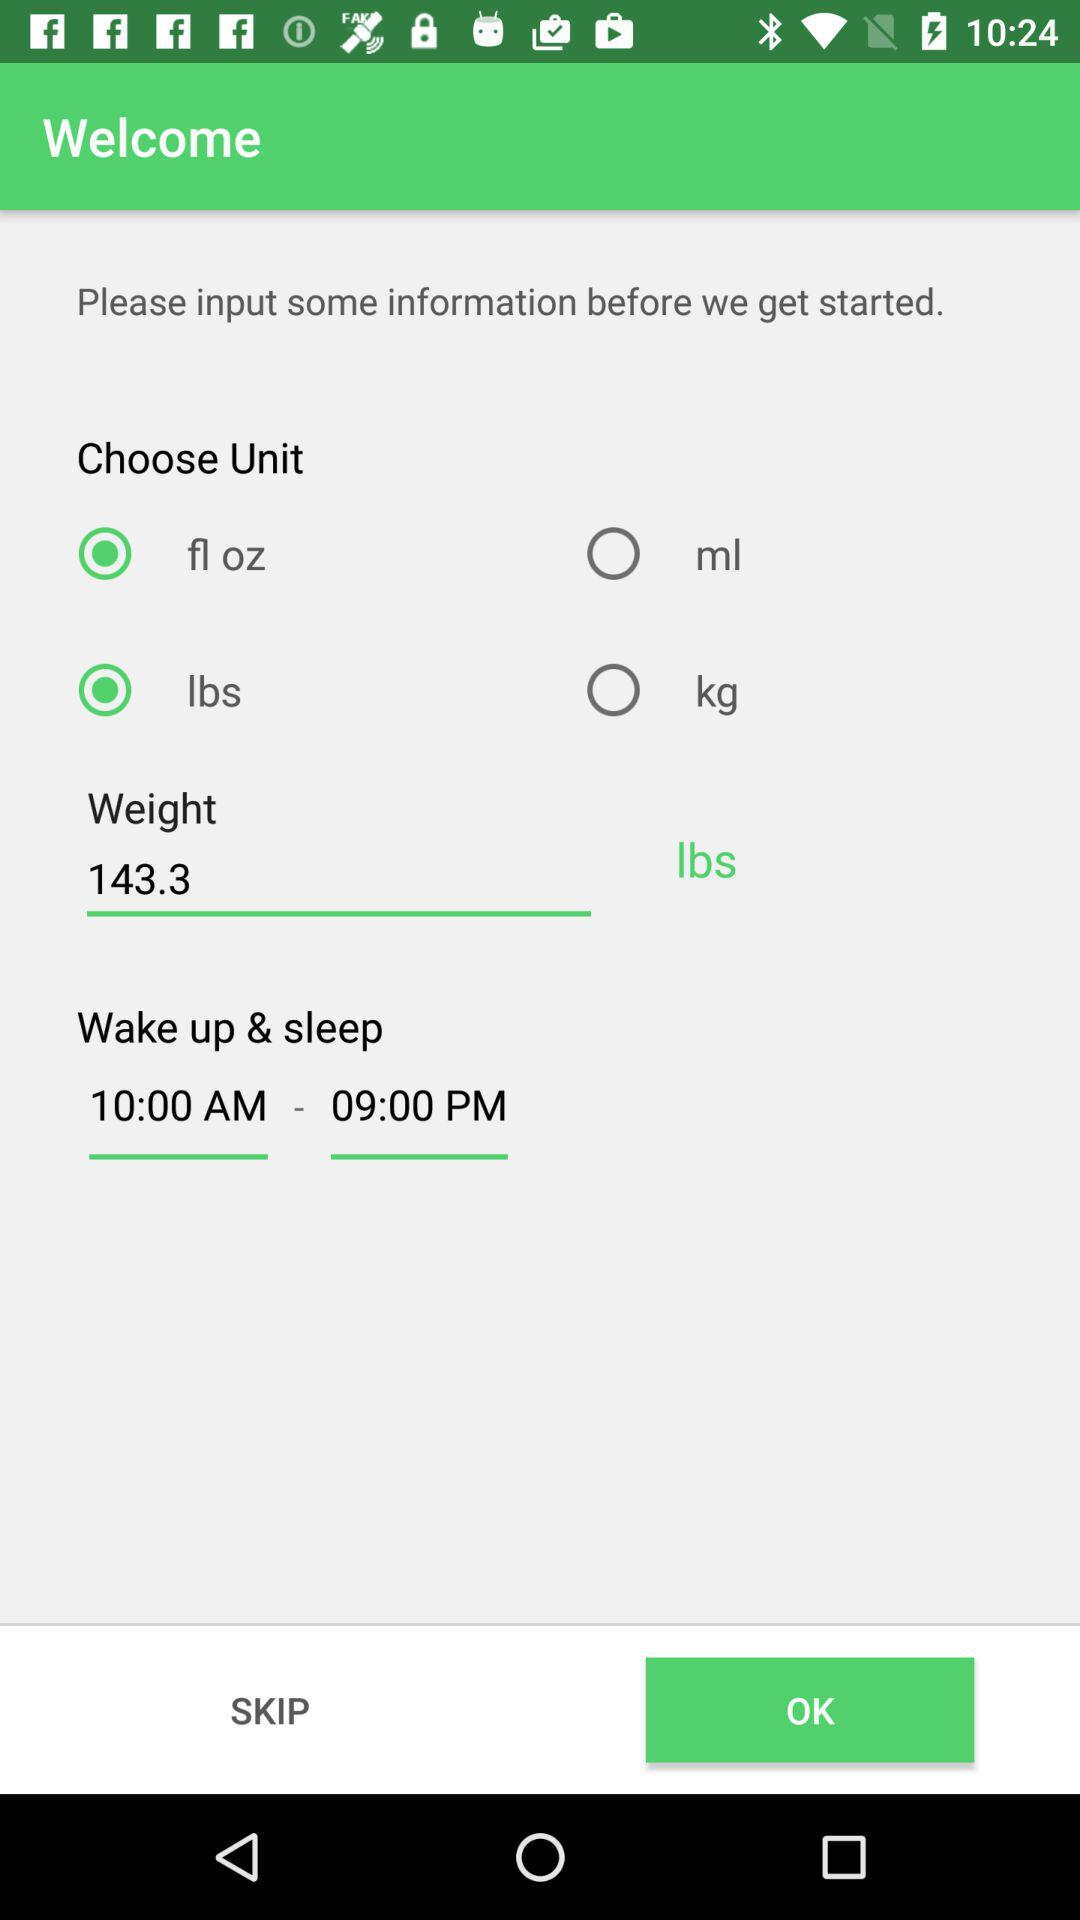What is the weight? The weight is 143.3 lbs. 